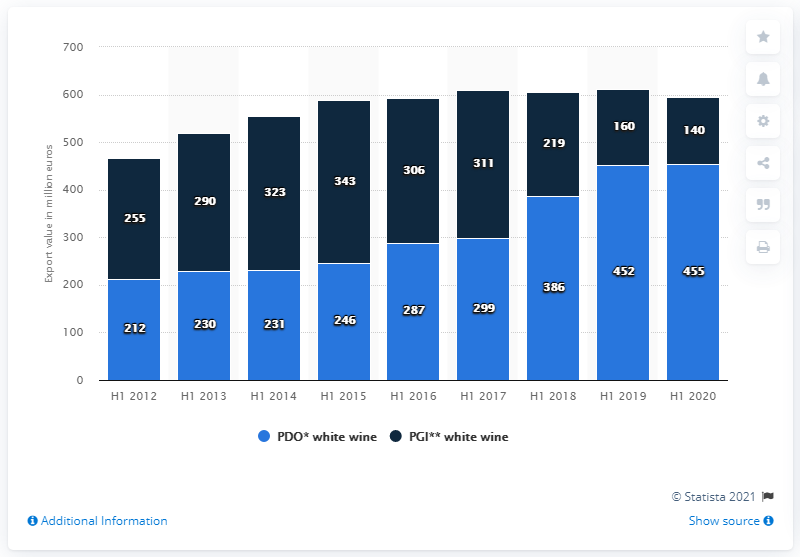Specify some key components in this picture. The export value of Italian PDO white wines in the first semester of 2020 was 455 million dollars. The export value of Italian PGI white wines in the first half of 2020 was 140 million dollars. 